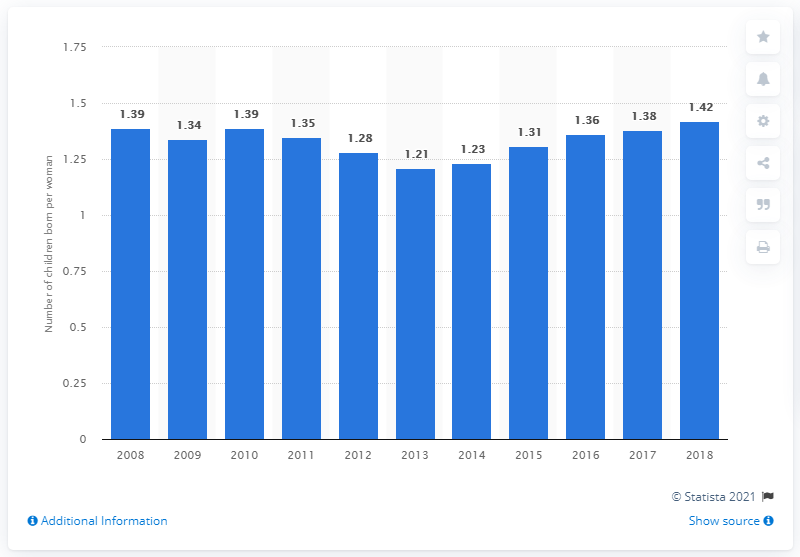Outline some significant characteristics in this image. The fertility rate in Portugal in 2018 was 1.42. 